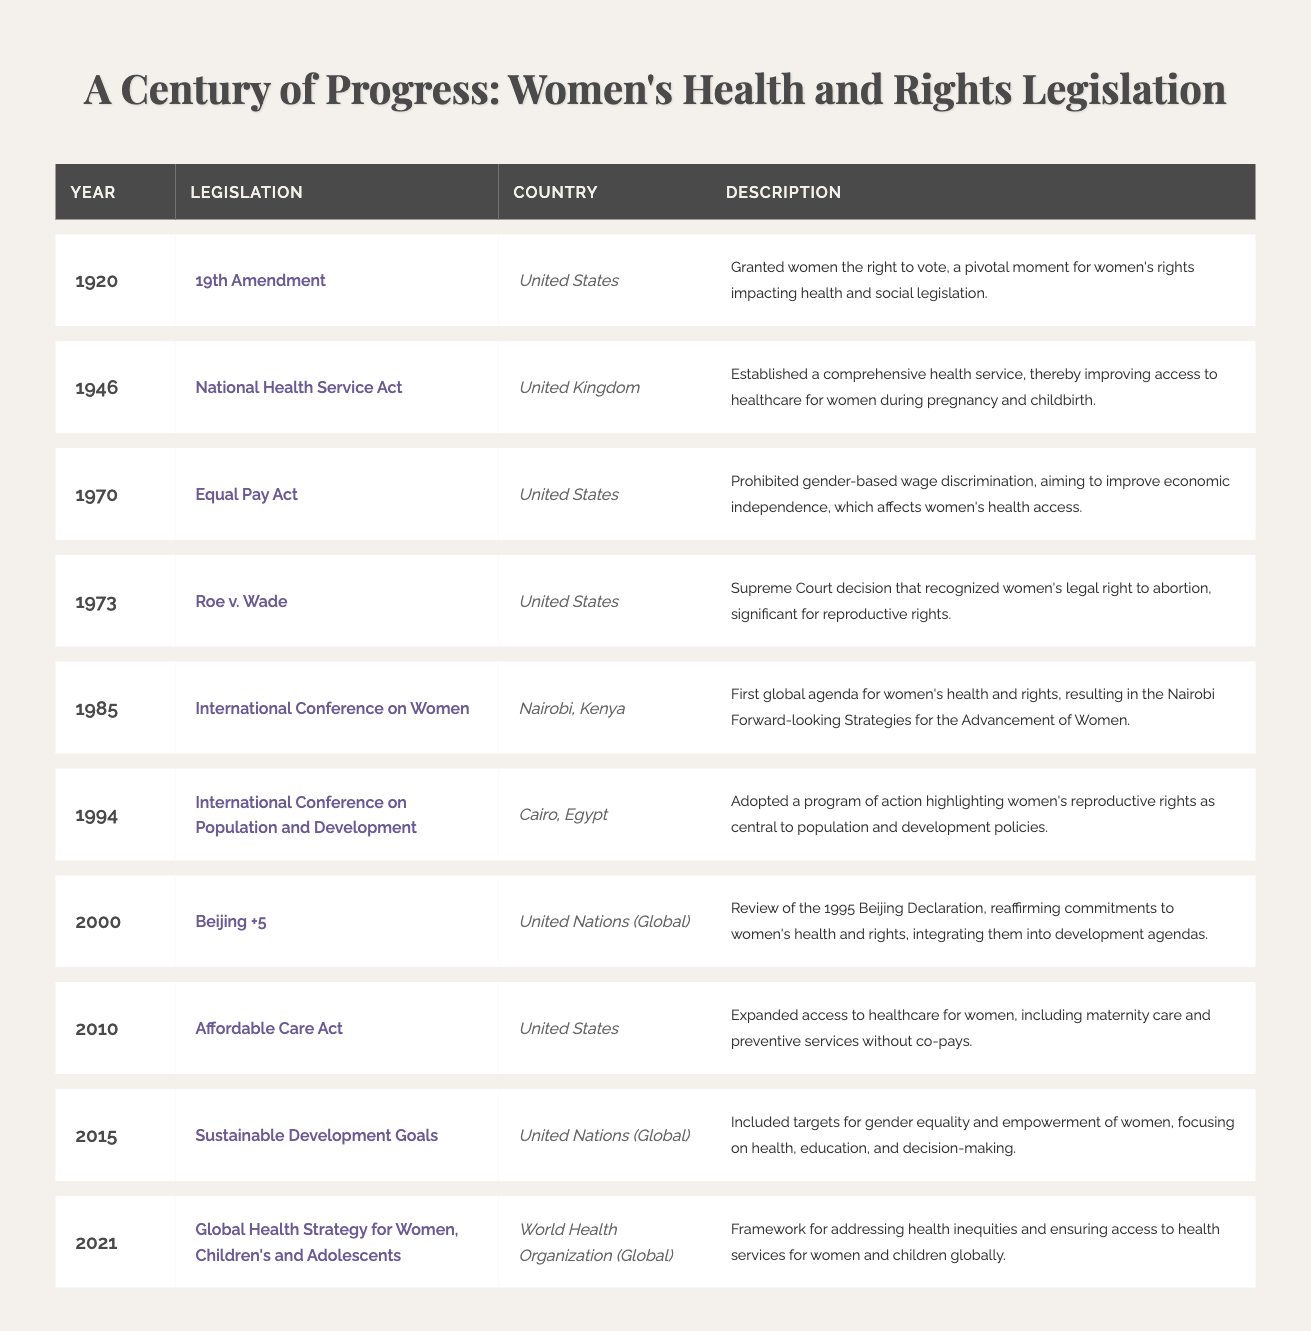What legislation was enacted in 1946? According to the table, the legislation enacted in 1946 is the "National Health Service Act." It is mentioned in the corresponding row for that year.
Answer: National Health Service Act Which country passed the 19th Amendment? The table indicates that the 19th Amendment was passed in the United States, as shown in the row for the year 1920.
Answer: United States What is the significance of Roe v. Wade? The description for Roe v. Wade in 1973 notes that it recognized women's legal right to abortion, making it significant for reproductive rights.
Answer: It recognized women's legal right to abortion How many legislations occurred in the 2000s? The table includes two legislations in the 2000s: "Beijing +5" in 2000 and "Affordable Care Act" in 2010, hence there are two legislations from that decade.
Answer: 2 Was the International Conference on Women held in 1985 significant for women’s rights? Yes, the table's description states that it resulted in the Nairobi Forward-looking Strategies for the Advancement of Women, indicating its significance.
Answer: Yes What year did the United States pass legislation related to equal pay? The Equal Pay Act was passed in the United States in the year 1970, as noted in the respective row in the table.
Answer: 1970 What percentage of the listed legislations took place after 1980? There are 6 legislations after 1980 (from 1985 to 2021) out of a total of 10. To find the percentage: (6/10) * 100 = 60%.
Answer: 60% Which legislation aimed to improve maternal and preventive care? The Affordable Care Act from 2010, as per the description, aimed to expand access to healthcare for women, including maternity care and preventive services.
Answer: Affordable Care Act Did the World Health Organization publish a Global Health Strategy for women in 2021? Yes, the table confirms that the Global Health Strategy for Women, Children's and Adolescents was published by the World Health Organization in 2021.
Answer: Yes What trend can be observed in women’s health legislation over time? By analyzing the table, one can observe a trend toward expanding women's rights and health access, particularly noted in legislation post-1980, reflecting increased attention to these issues globally.
Answer: Increasing focus on women's rights and health 